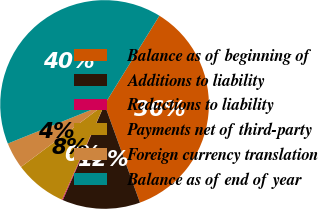<chart> <loc_0><loc_0><loc_500><loc_500><pie_chart><fcel>Balance as of beginning of<fcel>Additions to liability<fcel>Reductions to liability<fcel>Payments net of third-party<fcel>Foreign currency translation<fcel>Balance as of end of year<nl><fcel>35.68%<fcel>12.07%<fcel>0.13%<fcel>8.09%<fcel>4.11%<fcel>39.92%<nl></chart> 